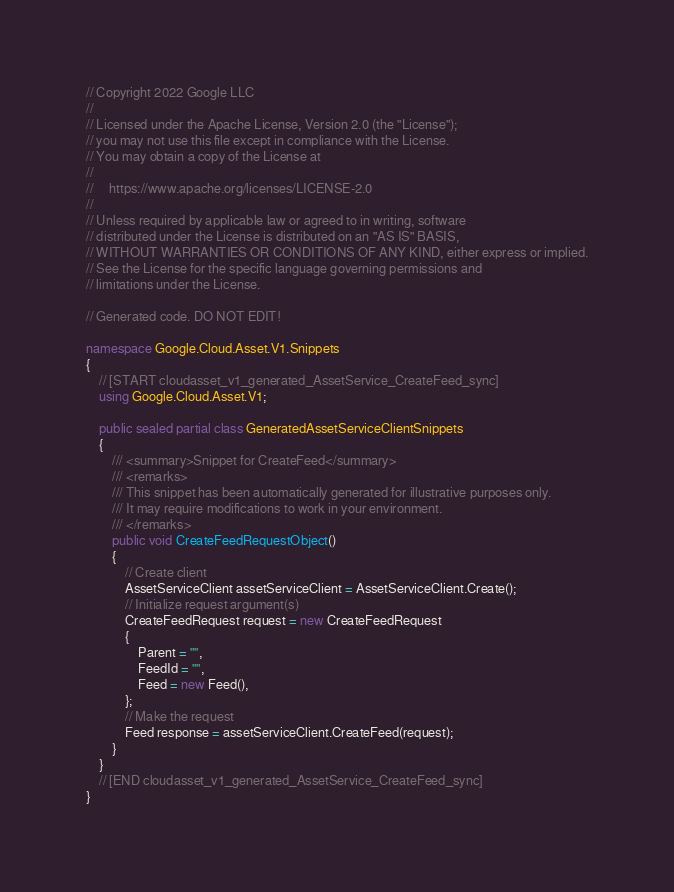<code> <loc_0><loc_0><loc_500><loc_500><_C#_>// Copyright 2022 Google LLC
//
// Licensed under the Apache License, Version 2.0 (the "License");
// you may not use this file except in compliance with the License.
// You may obtain a copy of the License at
//
//     https://www.apache.org/licenses/LICENSE-2.0
//
// Unless required by applicable law or agreed to in writing, software
// distributed under the License is distributed on an "AS IS" BASIS,
// WITHOUT WARRANTIES OR CONDITIONS OF ANY KIND, either express or implied.
// See the License for the specific language governing permissions and
// limitations under the License.

// Generated code. DO NOT EDIT!

namespace Google.Cloud.Asset.V1.Snippets
{
    // [START cloudasset_v1_generated_AssetService_CreateFeed_sync]
    using Google.Cloud.Asset.V1;

    public sealed partial class GeneratedAssetServiceClientSnippets
    {
        /// <summary>Snippet for CreateFeed</summary>
        /// <remarks>
        /// This snippet has been automatically generated for illustrative purposes only.
        /// It may require modifications to work in your environment.
        /// </remarks>
        public void CreateFeedRequestObject()
        {
            // Create client
            AssetServiceClient assetServiceClient = AssetServiceClient.Create();
            // Initialize request argument(s)
            CreateFeedRequest request = new CreateFeedRequest
            {
                Parent = "",
                FeedId = "",
                Feed = new Feed(),
            };
            // Make the request
            Feed response = assetServiceClient.CreateFeed(request);
        }
    }
    // [END cloudasset_v1_generated_AssetService_CreateFeed_sync]
}
</code> 